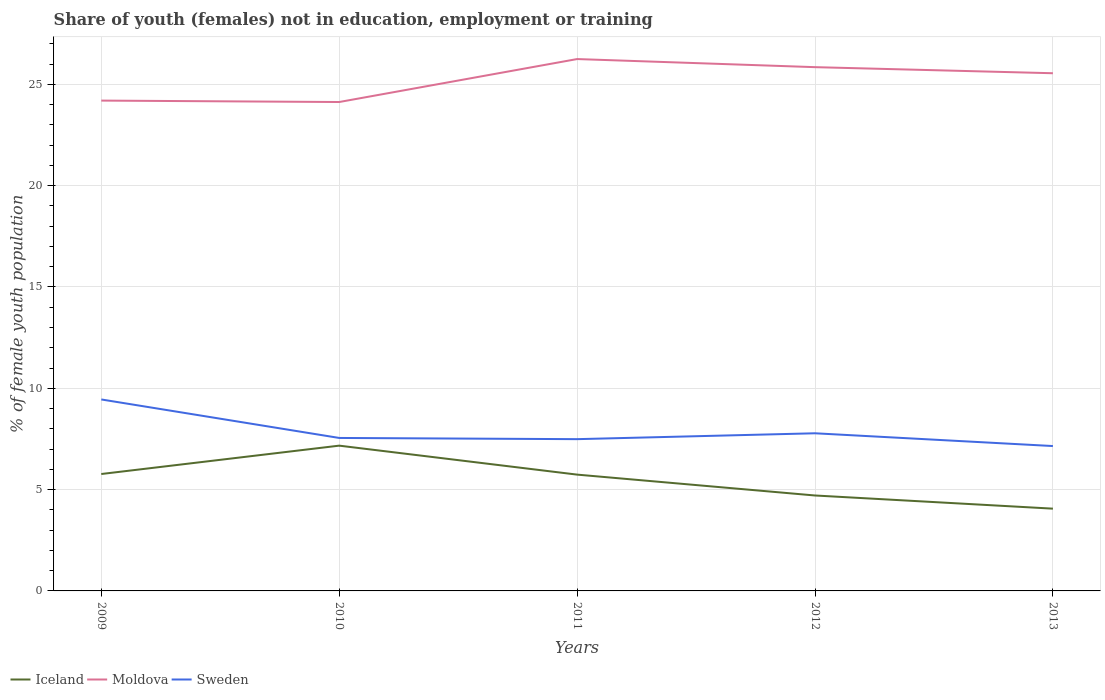Is the number of lines equal to the number of legend labels?
Offer a terse response. Yes. Across all years, what is the maximum percentage of unemployed female population in in Moldova?
Provide a short and direct response. 24.13. What is the total percentage of unemployed female population in in Moldova in the graph?
Your answer should be compact. -1.65. What is the difference between the highest and the second highest percentage of unemployed female population in in Iceland?
Provide a short and direct response. 3.11. What is the difference between the highest and the lowest percentage of unemployed female population in in Iceland?
Make the answer very short. 3. How many years are there in the graph?
Provide a succinct answer. 5. How are the legend labels stacked?
Your response must be concise. Horizontal. What is the title of the graph?
Make the answer very short. Share of youth (females) not in education, employment or training. Does "Croatia" appear as one of the legend labels in the graph?
Your answer should be very brief. No. What is the label or title of the Y-axis?
Keep it short and to the point. % of female youth population. What is the % of female youth population of Iceland in 2009?
Give a very brief answer. 5.77. What is the % of female youth population of Moldova in 2009?
Your response must be concise. 24.2. What is the % of female youth population in Sweden in 2009?
Your answer should be compact. 9.45. What is the % of female youth population of Iceland in 2010?
Offer a very short reply. 7.17. What is the % of female youth population of Moldova in 2010?
Keep it short and to the point. 24.13. What is the % of female youth population in Sweden in 2010?
Provide a short and direct response. 7.55. What is the % of female youth population in Iceland in 2011?
Offer a terse response. 5.74. What is the % of female youth population of Moldova in 2011?
Give a very brief answer. 26.25. What is the % of female youth population of Sweden in 2011?
Your response must be concise. 7.49. What is the % of female youth population in Iceland in 2012?
Make the answer very short. 4.71. What is the % of female youth population in Moldova in 2012?
Your answer should be very brief. 25.85. What is the % of female youth population in Sweden in 2012?
Ensure brevity in your answer.  7.78. What is the % of female youth population of Iceland in 2013?
Offer a very short reply. 4.06. What is the % of female youth population of Moldova in 2013?
Keep it short and to the point. 25.55. What is the % of female youth population in Sweden in 2013?
Make the answer very short. 7.15. Across all years, what is the maximum % of female youth population of Iceland?
Ensure brevity in your answer.  7.17. Across all years, what is the maximum % of female youth population in Moldova?
Give a very brief answer. 26.25. Across all years, what is the maximum % of female youth population in Sweden?
Offer a terse response. 9.45. Across all years, what is the minimum % of female youth population in Iceland?
Provide a succinct answer. 4.06. Across all years, what is the minimum % of female youth population of Moldova?
Provide a short and direct response. 24.13. Across all years, what is the minimum % of female youth population in Sweden?
Your response must be concise. 7.15. What is the total % of female youth population of Iceland in the graph?
Your response must be concise. 27.45. What is the total % of female youth population in Moldova in the graph?
Keep it short and to the point. 125.98. What is the total % of female youth population of Sweden in the graph?
Provide a short and direct response. 39.42. What is the difference between the % of female youth population in Iceland in 2009 and that in 2010?
Make the answer very short. -1.4. What is the difference between the % of female youth population in Moldova in 2009 and that in 2010?
Ensure brevity in your answer.  0.07. What is the difference between the % of female youth population of Sweden in 2009 and that in 2010?
Your answer should be compact. 1.9. What is the difference between the % of female youth population in Moldova in 2009 and that in 2011?
Provide a short and direct response. -2.05. What is the difference between the % of female youth population in Sweden in 2009 and that in 2011?
Provide a short and direct response. 1.96. What is the difference between the % of female youth population of Iceland in 2009 and that in 2012?
Make the answer very short. 1.06. What is the difference between the % of female youth population of Moldova in 2009 and that in 2012?
Provide a succinct answer. -1.65. What is the difference between the % of female youth population in Sweden in 2009 and that in 2012?
Offer a terse response. 1.67. What is the difference between the % of female youth population of Iceland in 2009 and that in 2013?
Keep it short and to the point. 1.71. What is the difference between the % of female youth population of Moldova in 2009 and that in 2013?
Your response must be concise. -1.35. What is the difference between the % of female youth population in Iceland in 2010 and that in 2011?
Offer a very short reply. 1.43. What is the difference between the % of female youth population in Moldova in 2010 and that in 2011?
Your answer should be very brief. -2.12. What is the difference between the % of female youth population in Iceland in 2010 and that in 2012?
Offer a terse response. 2.46. What is the difference between the % of female youth population of Moldova in 2010 and that in 2012?
Your answer should be compact. -1.72. What is the difference between the % of female youth population of Sweden in 2010 and that in 2012?
Give a very brief answer. -0.23. What is the difference between the % of female youth population in Iceland in 2010 and that in 2013?
Offer a terse response. 3.11. What is the difference between the % of female youth population of Moldova in 2010 and that in 2013?
Ensure brevity in your answer.  -1.42. What is the difference between the % of female youth population of Sweden in 2010 and that in 2013?
Keep it short and to the point. 0.4. What is the difference between the % of female youth population in Iceland in 2011 and that in 2012?
Give a very brief answer. 1.03. What is the difference between the % of female youth population in Sweden in 2011 and that in 2012?
Provide a succinct answer. -0.29. What is the difference between the % of female youth population of Iceland in 2011 and that in 2013?
Your response must be concise. 1.68. What is the difference between the % of female youth population of Moldova in 2011 and that in 2013?
Your answer should be compact. 0.7. What is the difference between the % of female youth population in Sweden in 2011 and that in 2013?
Offer a very short reply. 0.34. What is the difference between the % of female youth population of Iceland in 2012 and that in 2013?
Your response must be concise. 0.65. What is the difference between the % of female youth population of Moldova in 2012 and that in 2013?
Give a very brief answer. 0.3. What is the difference between the % of female youth population of Sweden in 2012 and that in 2013?
Make the answer very short. 0.63. What is the difference between the % of female youth population of Iceland in 2009 and the % of female youth population of Moldova in 2010?
Provide a succinct answer. -18.36. What is the difference between the % of female youth population in Iceland in 2009 and the % of female youth population in Sweden in 2010?
Your answer should be very brief. -1.78. What is the difference between the % of female youth population of Moldova in 2009 and the % of female youth population of Sweden in 2010?
Give a very brief answer. 16.65. What is the difference between the % of female youth population in Iceland in 2009 and the % of female youth population in Moldova in 2011?
Your answer should be very brief. -20.48. What is the difference between the % of female youth population in Iceland in 2009 and the % of female youth population in Sweden in 2011?
Give a very brief answer. -1.72. What is the difference between the % of female youth population of Moldova in 2009 and the % of female youth population of Sweden in 2011?
Give a very brief answer. 16.71. What is the difference between the % of female youth population in Iceland in 2009 and the % of female youth population in Moldova in 2012?
Make the answer very short. -20.08. What is the difference between the % of female youth population in Iceland in 2009 and the % of female youth population in Sweden in 2012?
Provide a short and direct response. -2.01. What is the difference between the % of female youth population in Moldova in 2009 and the % of female youth population in Sweden in 2012?
Ensure brevity in your answer.  16.42. What is the difference between the % of female youth population of Iceland in 2009 and the % of female youth population of Moldova in 2013?
Your answer should be very brief. -19.78. What is the difference between the % of female youth population of Iceland in 2009 and the % of female youth population of Sweden in 2013?
Provide a short and direct response. -1.38. What is the difference between the % of female youth population in Moldova in 2009 and the % of female youth population in Sweden in 2013?
Give a very brief answer. 17.05. What is the difference between the % of female youth population in Iceland in 2010 and the % of female youth population in Moldova in 2011?
Offer a very short reply. -19.08. What is the difference between the % of female youth population of Iceland in 2010 and the % of female youth population of Sweden in 2011?
Offer a terse response. -0.32. What is the difference between the % of female youth population of Moldova in 2010 and the % of female youth population of Sweden in 2011?
Give a very brief answer. 16.64. What is the difference between the % of female youth population in Iceland in 2010 and the % of female youth population in Moldova in 2012?
Offer a terse response. -18.68. What is the difference between the % of female youth population in Iceland in 2010 and the % of female youth population in Sweden in 2012?
Your answer should be compact. -0.61. What is the difference between the % of female youth population in Moldova in 2010 and the % of female youth population in Sweden in 2012?
Ensure brevity in your answer.  16.35. What is the difference between the % of female youth population in Iceland in 2010 and the % of female youth population in Moldova in 2013?
Provide a short and direct response. -18.38. What is the difference between the % of female youth population in Moldova in 2010 and the % of female youth population in Sweden in 2013?
Offer a terse response. 16.98. What is the difference between the % of female youth population in Iceland in 2011 and the % of female youth population in Moldova in 2012?
Offer a very short reply. -20.11. What is the difference between the % of female youth population in Iceland in 2011 and the % of female youth population in Sweden in 2012?
Give a very brief answer. -2.04. What is the difference between the % of female youth population in Moldova in 2011 and the % of female youth population in Sweden in 2012?
Ensure brevity in your answer.  18.47. What is the difference between the % of female youth population of Iceland in 2011 and the % of female youth population of Moldova in 2013?
Offer a very short reply. -19.81. What is the difference between the % of female youth population in Iceland in 2011 and the % of female youth population in Sweden in 2013?
Give a very brief answer. -1.41. What is the difference between the % of female youth population of Moldova in 2011 and the % of female youth population of Sweden in 2013?
Offer a very short reply. 19.1. What is the difference between the % of female youth population in Iceland in 2012 and the % of female youth population in Moldova in 2013?
Your answer should be very brief. -20.84. What is the difference between the % of female youth population of Iceland in 2012 and the % of female youth population of Sweden in 2013?
Keep it short and to the point. -2.44. What is the difference between the % of female youth population of Moldova in 2012 and the % of female youth population of Sweden in 2013?
Provide a succinct answer. 18.7. What is the average % of female youth population in Iceland per year?
Your response must be concise. 5.49. What is the average % of female youth population in Moldova per year?
Make the answer very short. 25.2. What is the average % of female youth population in Sweden per year?
Give a very brief answer. 7.88. In the year 2009, what is the difference between the % of female youth population in Iceland and % of female youth population in Moldova?
Provide a succinct answer. -18.43. In the year 2009, what is the difference between the % of female youth population of Iceland and % of female youth population of Sweden?
Offer a very short reply. -3.68. In the year 2009, what is the difference between the % of female youth population in Moldova and % of female youth population in Sweden?
Your answer should be very brief. 14.75. In the year 2010, what is the difference between the % of female youth population of Iceland and % of female youth population of Moldova?
Your response must be concise. -16.96. In the year 2010, what is the difference between the % of female youth population of Iceland and % of female youth population of Sweden?
Your answer should be compact. -0.38. In the year 2010, what is the difference between the % of female youth population of Moldova and % of female youth population of Sweden?
Give a very brief answer. 16.58. In the year 2011, what is the difference between the % of female youth population of Iceland and % of female youth population of Moldova?
Provide a succinct answer. -20.51. In the year 2011, what is the difference between the % of female youth population in Iceland and % of female youth population in Sweden?
Make the answer very short. -1.75. In the year 2011, what is the difference between the % of female youth population of Moldova and % of female youth population of Sweden?
Offer a very short reply. 18.76. In the year 2012, what is the difference between the % of female youth population of Iceland and % of female youth population of Moldova?
Your answer should be compact. -21.14. In the year 2012, what is the difference between the % of female youth population in Iceland and % of female youth population in Sweden?
Make the answer very short. -3.07. In the year 2012, what is the difference between the % of female youth population of Moldova and % of female youth population of Sweden?
Your answer should be compact. 18.07. In the year 2013, what is the difference between the % of female youth population in Iceland and % of female youth population in Moldova?
Offer a very short reply. -21.49. In the year 2013, what is the difference between the % of female youth population in Iceland and % of female youth population in Sweden?
Give a very brief answer. -3.09. What is the ratio of the % of female youth population of Iceland in 2009 to that in 2010?
Your answer should be compact. 0.8. What is the ratio of the % of female youth population in Moldova in 2009 to that in 2010?
Make the answer very short. 1. What is the ratio of the % of female youth population in Sweden in 2009 to that in 2010?
Offer a terse response. 1.25. What is the ratio of the % of female youth population of Iceland in 2009 to that in 2011?
Your response must be concise. 1.01. What is the ratio of the % of female youth population of Moldova in 2009 to that in 2011?
Make the answer very short. 0.92. What is the ratio of the % of female youth population in Sweden in 2009 to that in 2011?
Your answer should be compact. 1.26. What is the ratio of the % of female youth population of Iceland in 2009 to that in 2012?
Offer a terse response. 1.23. What is the ratio of the % of female youth population in Moldova in 2009 to that in 2012?
Your answer should be very brief. 0.94. What is the ratio of the % of female youth population in Sweden in 2009 to that in 2012?
Ensure brevity in your answer.  1.21. What is the ratio of the % of female youth population of Iceland in 2009 to that in 2013?
Provide a short and direct response. 1.42. What is the ratio of the % of female youth population in Moldova in 2009 to that in 2013?
Provide a short and direct response. 0.95. What is the ratio of the % of female youth population in Sweden in 2009 to that in 2013?
Provide a short and direct response. 1.32. What is the ratio of the % of female youth population of Iceland in 2010 to that in 2011?
Your answer should be compact. 1.25. What is the ratio of the % of female youth population in Moldova in 2010 to that in 2011?
Make the answer very short. 0.92. What is the ratio of the % of female youth population of Iceland in 2010 to that in 2012?
Offer a terse response. 1.52. What is the ratio of the % of female youth population of Moldova in 2010 to that in 2012?
Keep it short and to the point. 0.93. What is the ratio of the % of female youth population of Sweden in 2010 to that in 2012?
Your answer should be compact. 0.97. What is the ratio of the % of female youth population of Iceland in 2010 to that in 2013?
Provide a succinct answer. 1.77. What is the ratio of the % of female youth population of Sweden in 2010 to that in 2013?
Offer a very short reply. 1.06. What is the ratio of the % of female youth population in Iceland in 2011 to that in 2012?
Provide a succinct answer. 1.22. What is the ratio of the % of female youth population of Moldova in 2011 to that in 2012?
Provide a succinct answer. 1.02. What is the ratio of the % of female youth population of Sweden in 2011 to that in 2012?
Your answer should be very brief. 0.96. What is the ratio of the % of female youth population of Iceland in 2011 to that in 2013?
Your answer should be very brief. 1.41. What is the ratio of the % of female youth population of Moldova in 2011 to that in 2013?
Provide a succinct answer. 1.03. What is the ratio of the % of female youth population of Sweden in 2011 to that in 2013?
Your answer should be compact. 1.05. What is the ratio of the % of female youth population in Iceland in 2012 to that in 2013?
Keep it short and to the point. 1.16. What is the ratio of the % of female youth population in Moldova in 2012 to that in 2013?
Give a very brief answer. 1.01. What is the ratio of the % of female youth population of Sweden in 2012 to that in 2013?
Your answer should be compact. 1.09. What is the difference between the highest and the second highest % of female youth population in Moldova?
Your response must be concise. 0.4. What is the difference between the highest and the second highest % of female youth population in Sweden?
Provide a succinct answer. 1.67. What is the difference between the highest and the lowest % of female youth population in Iceland?
Your answer should be compact. 3.11. What is the difference between the highest and the lowest % of female youth population in Moldova?
Keep it short and to the point. 2.12. What is the difference between the highest and the lowest % of female youth population in Sweden?
Give a very brief answer. 2.3. 